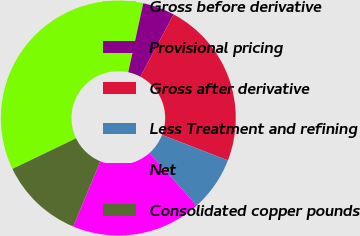<chart> <loc_0><loc_0><loc_500><loc_500><pie_chart><fcel>Gross before derivative<fcel>Provisional pricing<fcel>Gross after derivative<fcel>Less Treatment and refining<fcel>Net<fcel>Consolidated copper pounds<nl><fcel>35.54%<fcel>4.4%<fcel>23.06%<fcel>7.51%<fcel>17.89%<fcel>11.6%<nl></chart> 